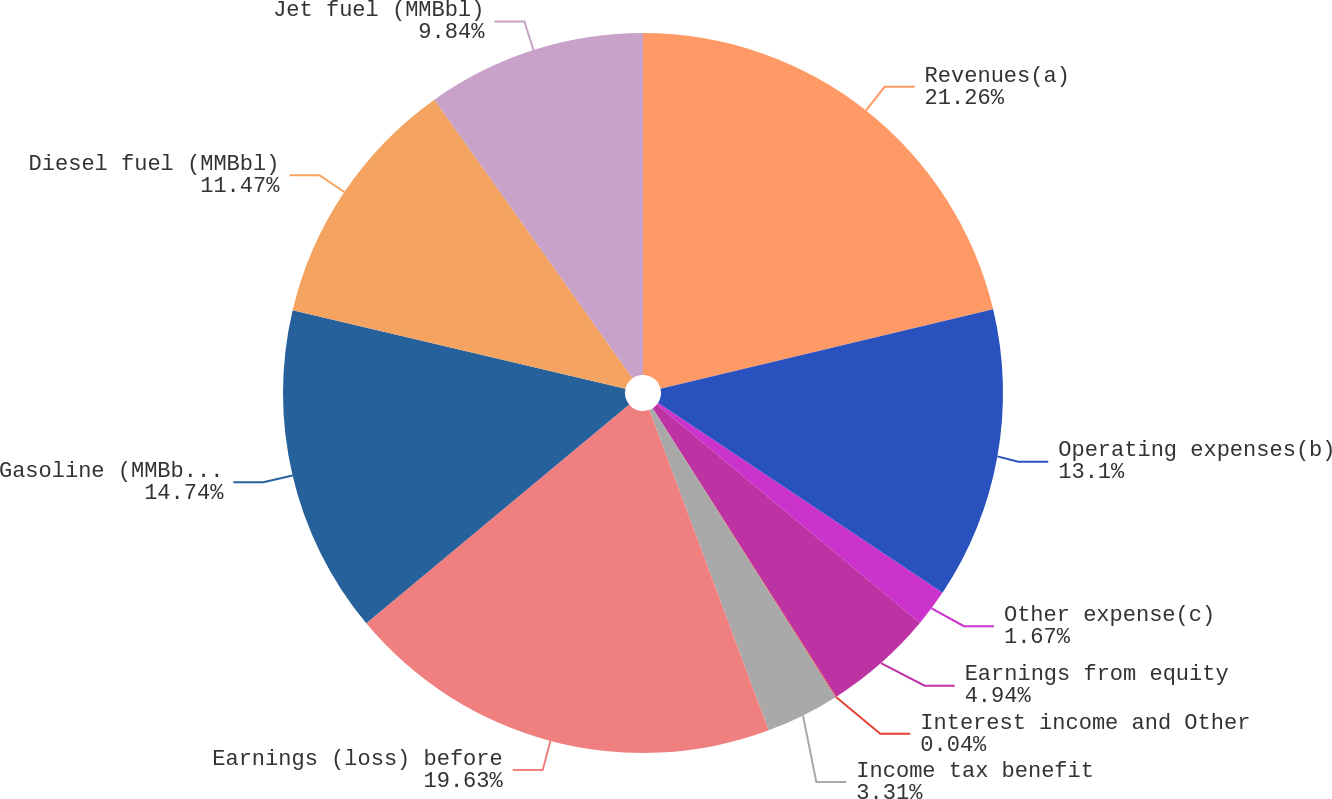Convert chart. <chart><loc_0><loc_0><loc_500><loc_500><pie_chart><fcel>Revenues(a)<fcel>Operating expenses(b)<fcel>Other expense(c)<fcel>Earnings from equity<fcel>Interest income and Other<fcel>Income tax benefit<fcel>Earnings (loss) before<fcel>Gasoline (MMBbl) (h)<fcel>Diesel fuel (MMBbl)<fcel>Jet fuel (MMBbl)<nl><fcel>21.27%<fcel>13.1%<fcel>1.67%<fcel>4.94%<fcel>0.04%<fcel>3.31%<fcel>19.63%<fcel>14.74%<fcel>11.47%<fcel>9.84%<nl></chart> 